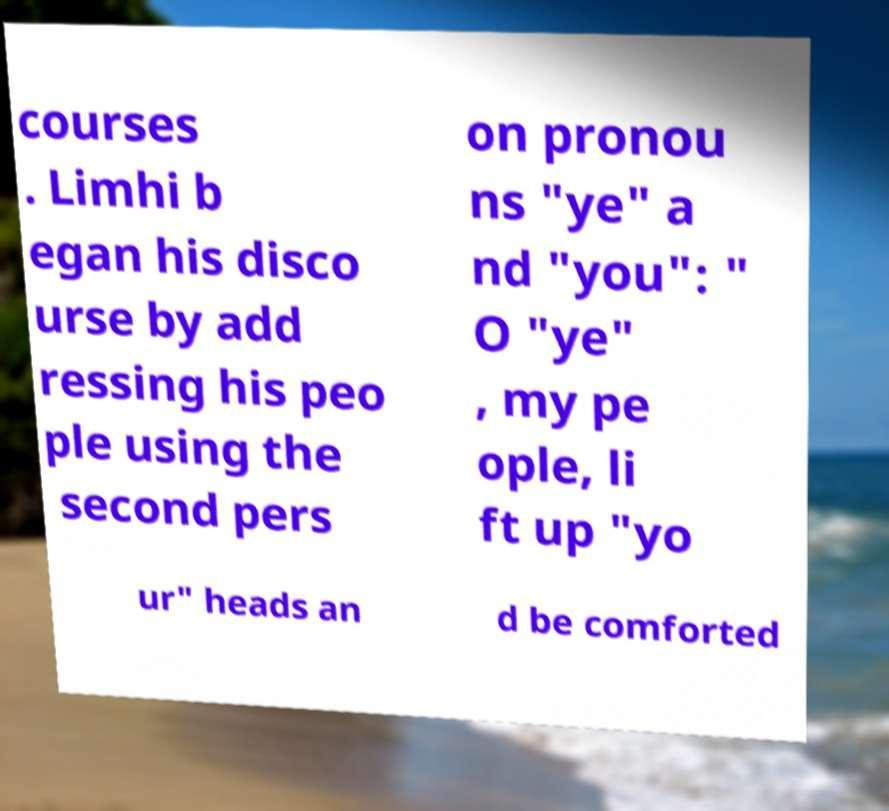There's text embedded in this image that I need extracted. Can you transcribe it verbatim? courses . Limhi b egan his disco urse by add ressing his peo ple using the second pers on pronou ns "ye" a nd "you": " O "ye" , my pe ople, li ft up "yo ur" heads an d be comforted 